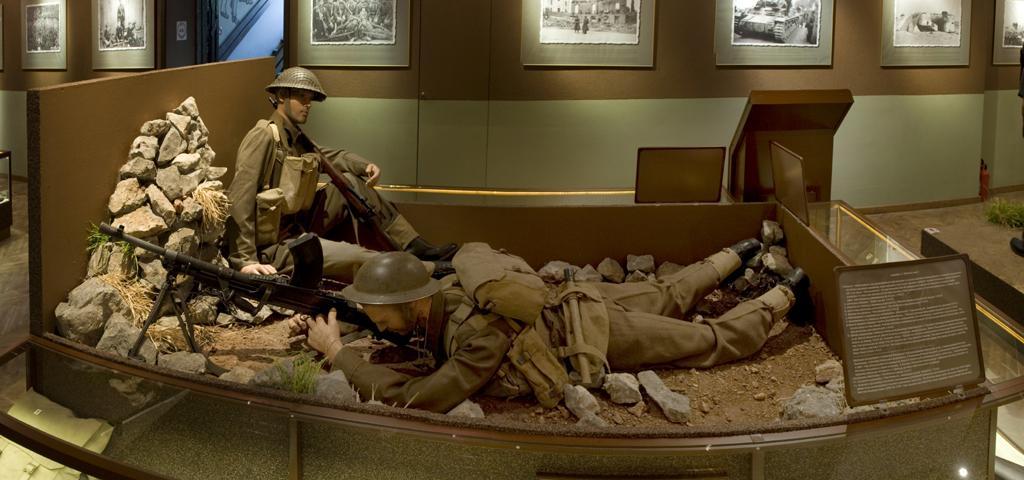Can you describe this image briefly? In this image, there are two statues of soldiers and stones in the foreground area of the image, there are frames at the top side. 